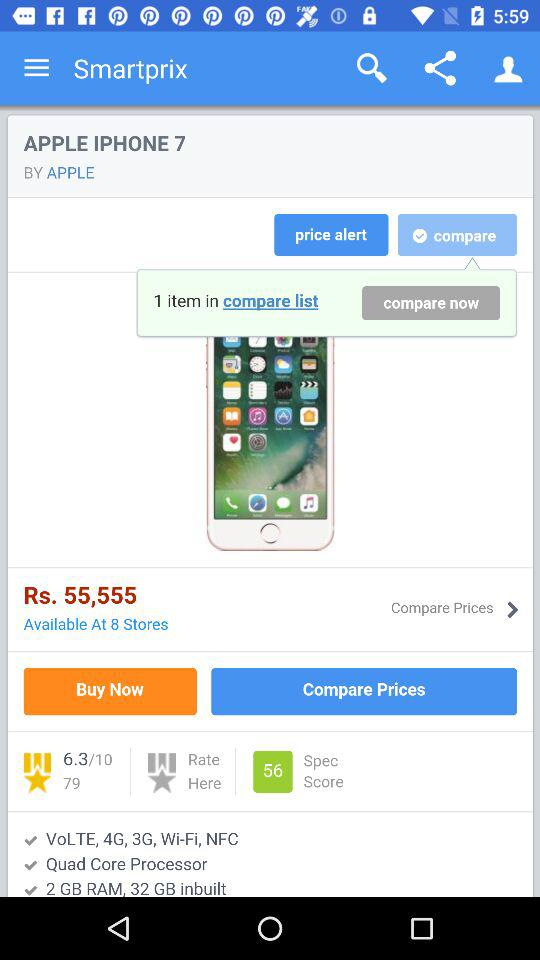What is the storage capacity of the iPhone 7? The storage capacity of the iPhone 7 is "2 GB RAM, 32 GB inbuilt". 